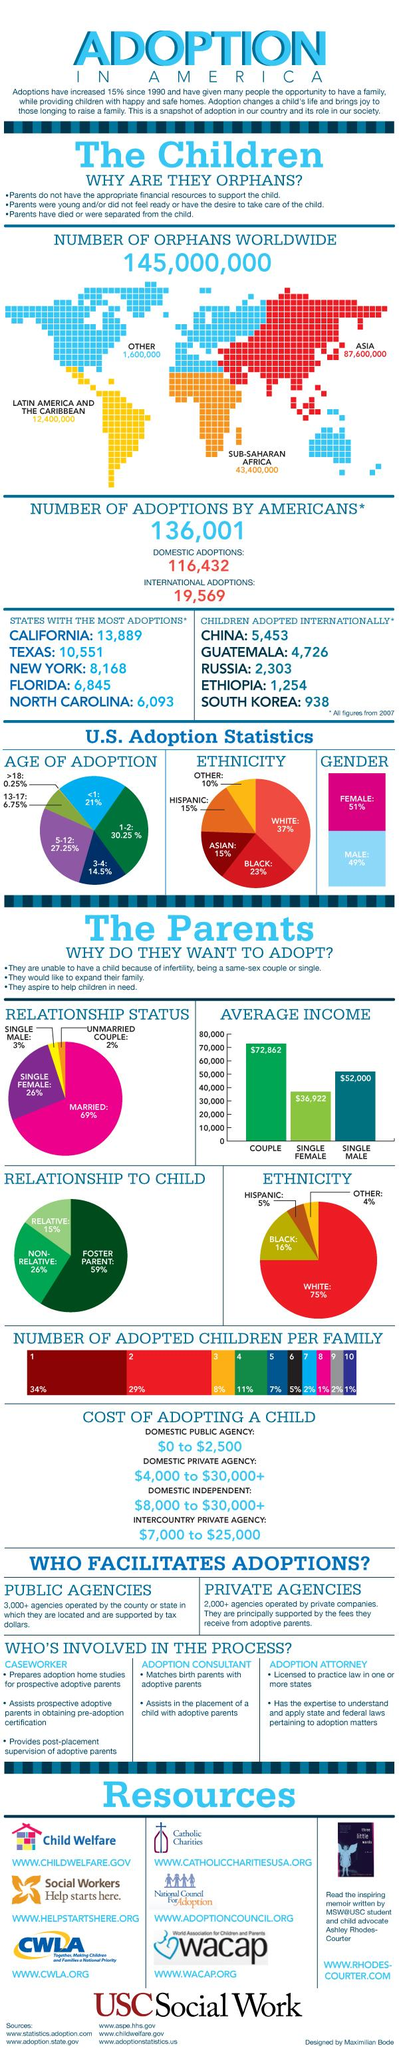Mention a couple of crucial points in this snapshot. In approximately 26% of cases, the children are not related. New York had the third highest number of adoptions. According to a recent survey, 15% of Asians participate in adoption. It is domestic public agencies that charge the least when it comes to adopting, rather than private agencies. It is the responsibility of an adoption attorney to handle legal matters related to adoption. 